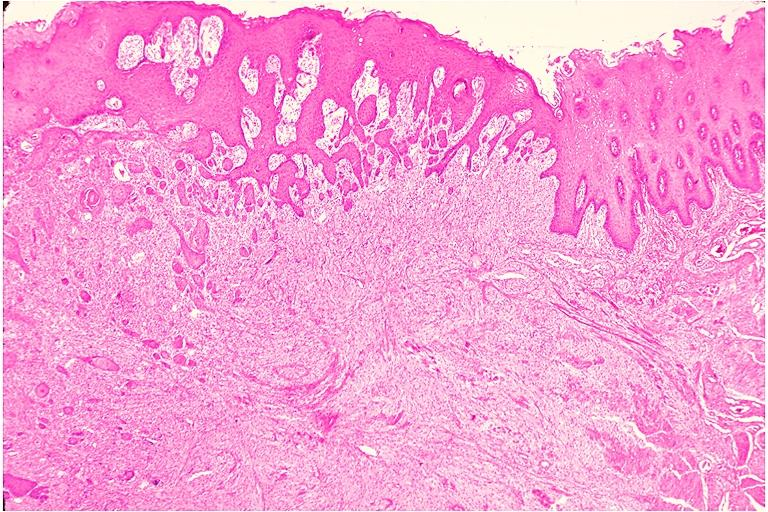where is this?
Answer the question using a single word or phrase. Oral 